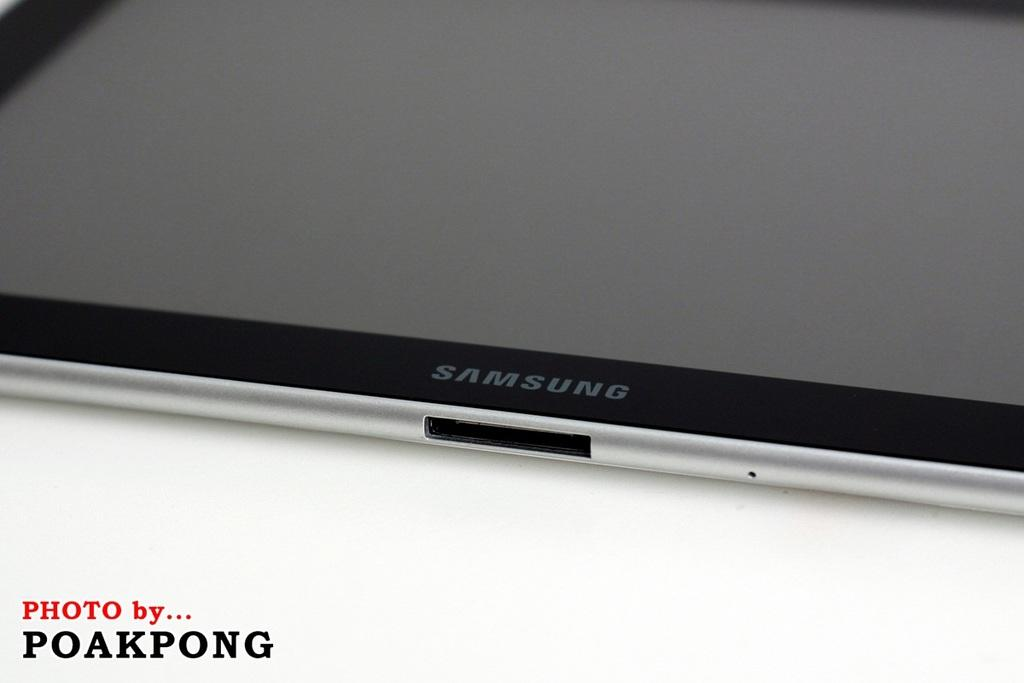<image>
Relay a brief, clear account of the picture shown. a photo of a samsung tablet by POAKPONG 